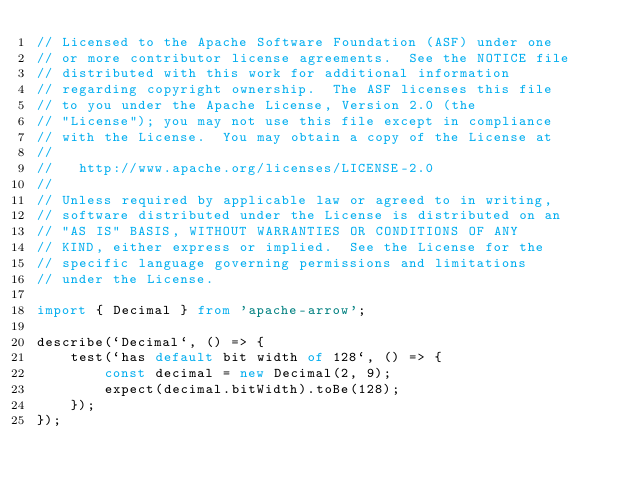Convert code to text. <code><loc_0><loc_0><loc_500><loc_500><_TypeScript_>// Licensed to the Apache Software Foundation (ASF) under one
// or more contributor license agreements.  See the NOTICE file
// distributed with this work for additional information
// regarding copyright ownership.  The ASF licenses this file
// to you under the Apache License, Version 2.0 (the
// "License"); you may not use this file except in compliance
// with the License.  You may obtain a copy of the License at
//
//   http://www.apache.org/licenses/LICENSE-2.0
//
// Unless required by applicable law or agreed to in writing,
// software distributed under the License is distributed on an
// "AS IS" BASIS, WITHOUT WARRANTIES OR CONDITIONS OF ANY
// KIND, either express or implied.  See the License for the
// specific language governing permissions and limitations
// under the License.

import { Decimal } from 'apache-arrow';

describe(`Decimal`, () => {
    test(`has default bit width of 128`, () => {
        const decimal = new Decimal(2, 9);
        expect(decimal.bitWidth).toBe(128);
    });
});
</code> 